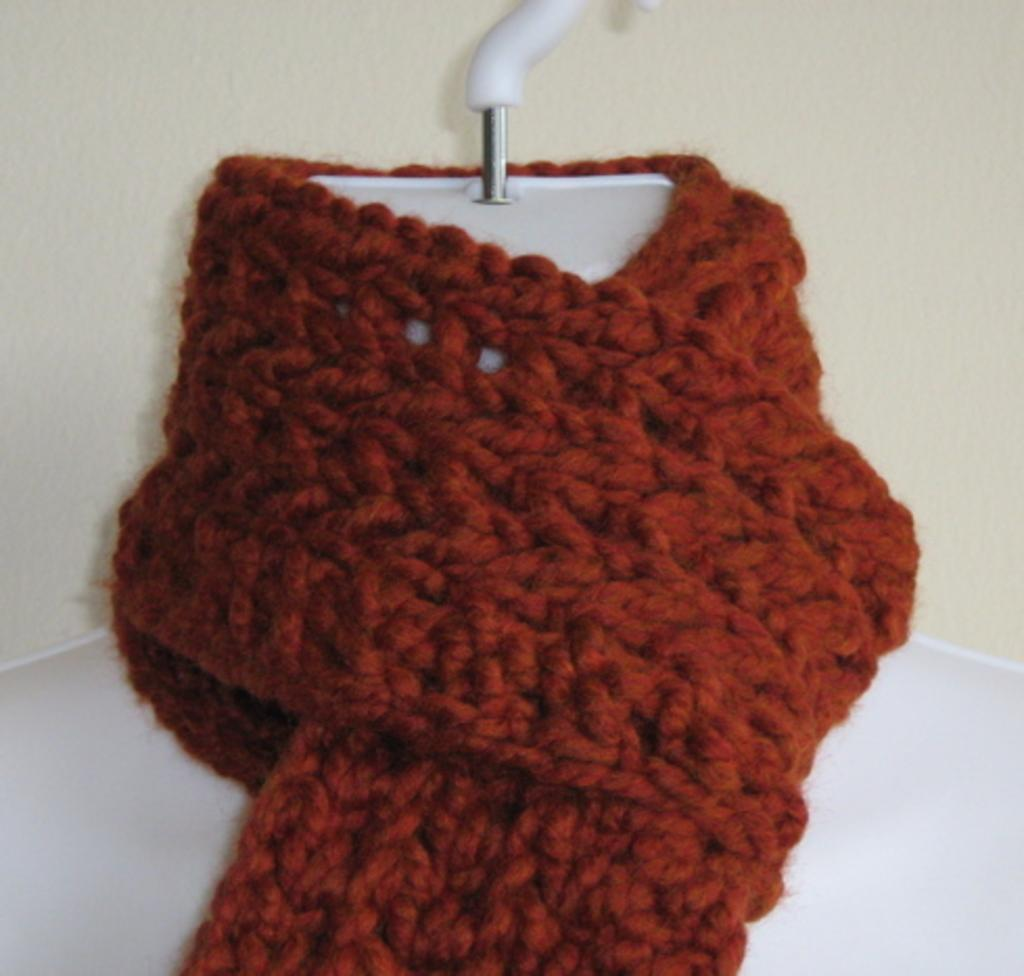What item is visible in the image? There is a neck scarf in the image. How is the neck scarf positioned in the image? The neck scarf is placed on a hanger. What can be seen in the background of the image? There is a wall in the background of the image. What type of texture can be seen on the fingers in the image? There are no fingers present in the image, so it is not possible to determine the texture of any fingers. 